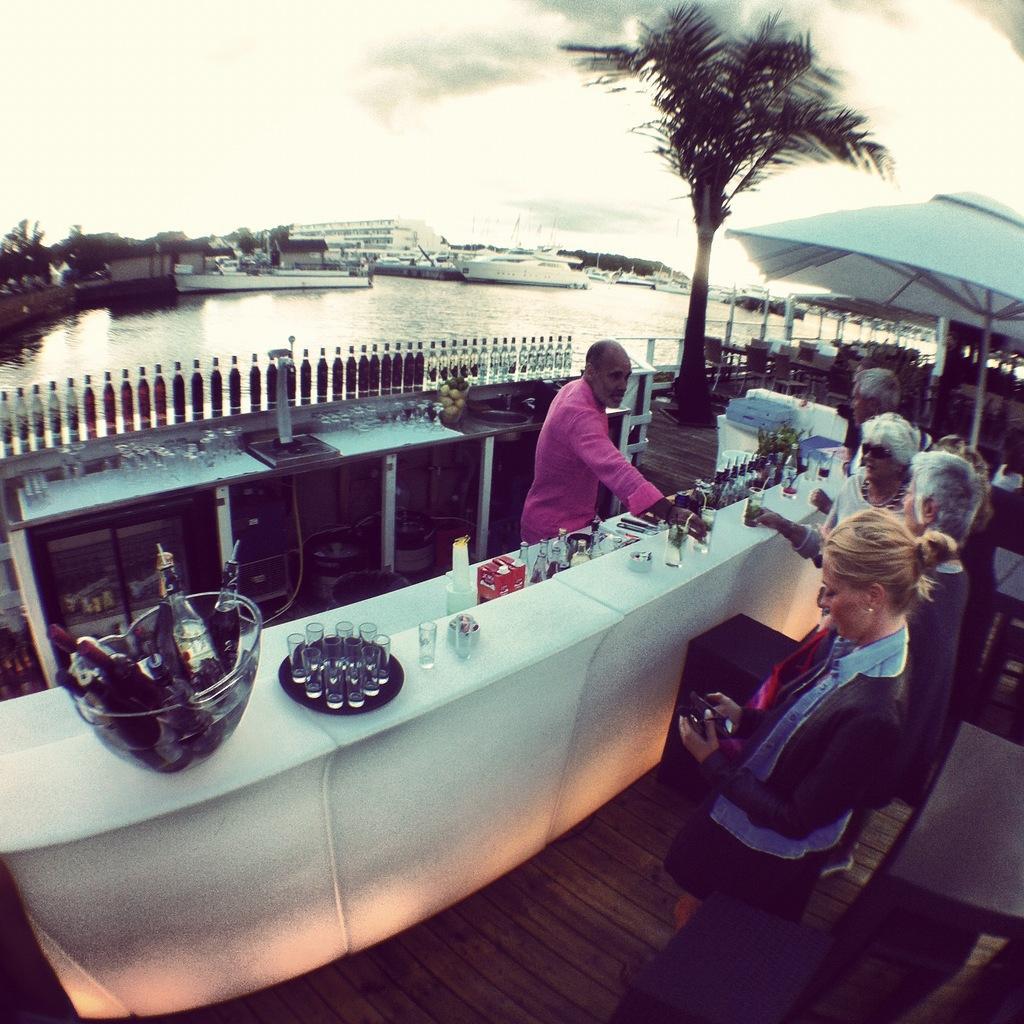Please provide a concise description of this image. Here we can see a cafeteria place where a man is serving the drinks to the group of people and also we have some bottles and a tree and behind them there is a sea. 